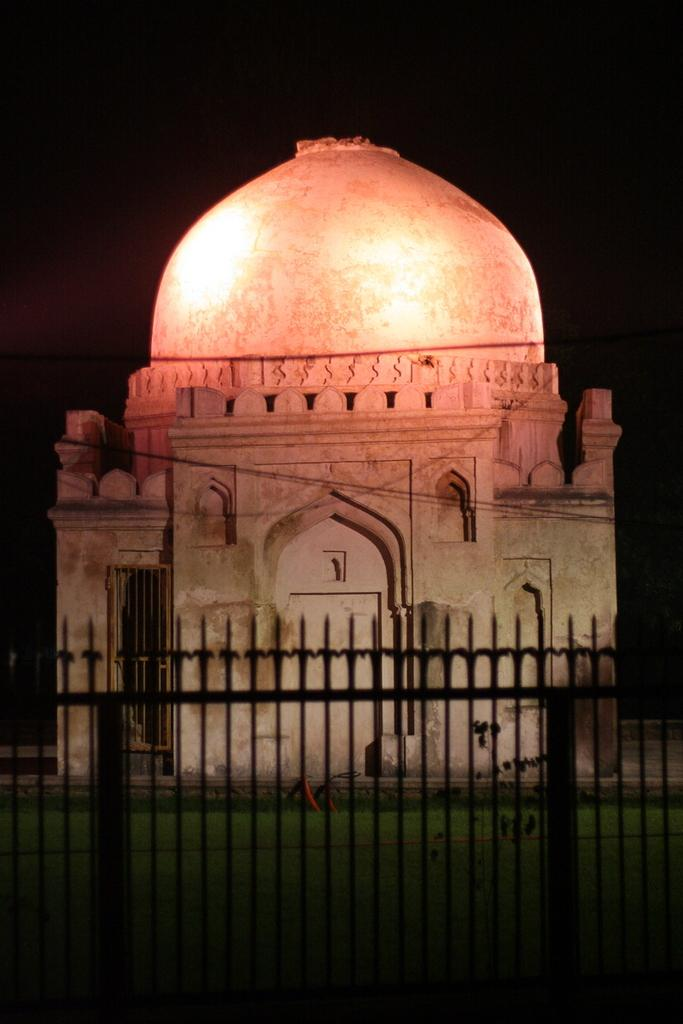What can be seen in the image that might be used for support or safety? There is a railing in the image that might be used for support or safety. What type of structure is visible in the image? There is a building in the image. What color is the background of the image? The background of the image is black. What time of day is it in the image, and is there a crook present? The time of day is not mentioned in the image, and there is no crook present. What type of vegetable is being used as a decoration in the image? There are no vegetables, including potatoes, present in the image. 